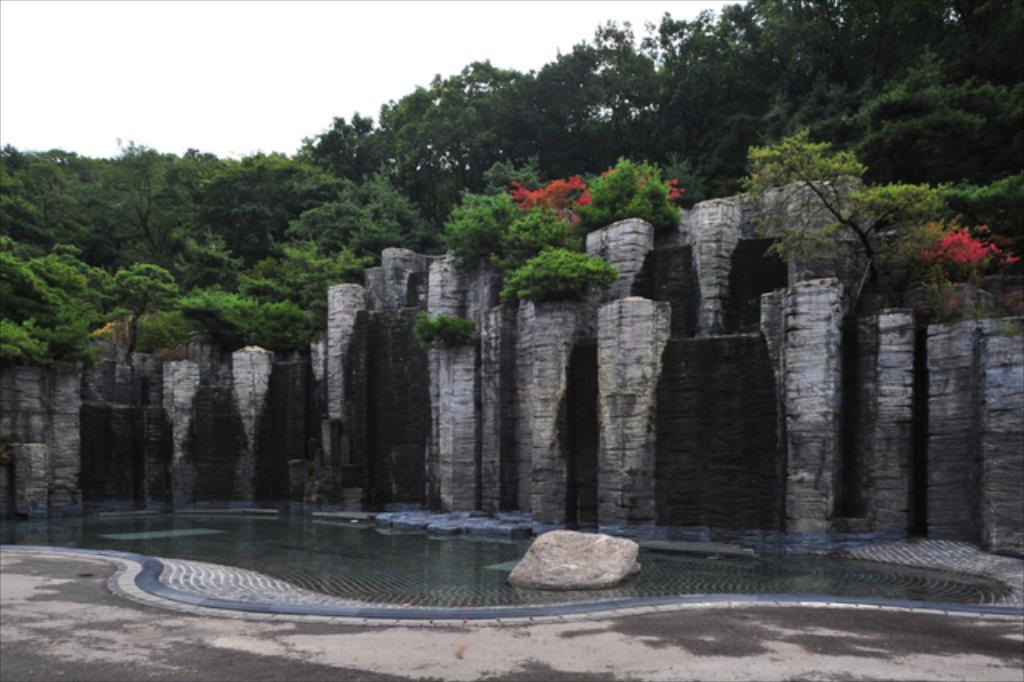What structures are located in the center of the image? There are pillars in the center of the image. What type of architectural feature can be seen in the image? There is a wall in the image. What type of vegetation is present? There are plants and trees in the image. What is located at the bottom of the image? There is a rock at the bottom of the image. What natural element is visible in the image? There is water visible in the image. What man-made feature can be seen in the image? There is a road in the image. What type of pump is visible in the image? There is no pump present in the image. Are there any pigs visible in the image? There are no pigs present in the image. 